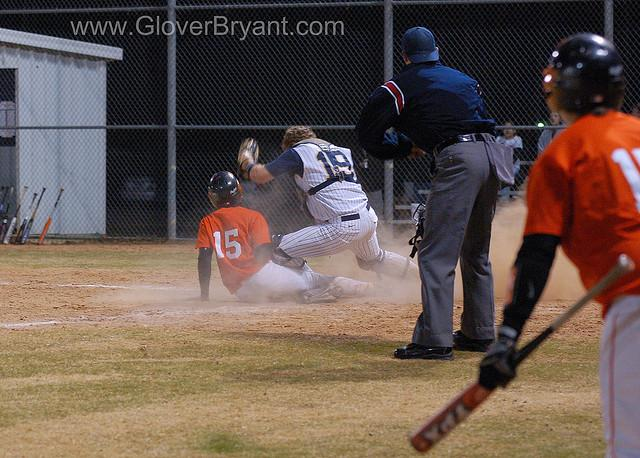What action caused the dust to fly?

Choices:
A) bats
B) waving arms
C) sliding
D) running sliding 